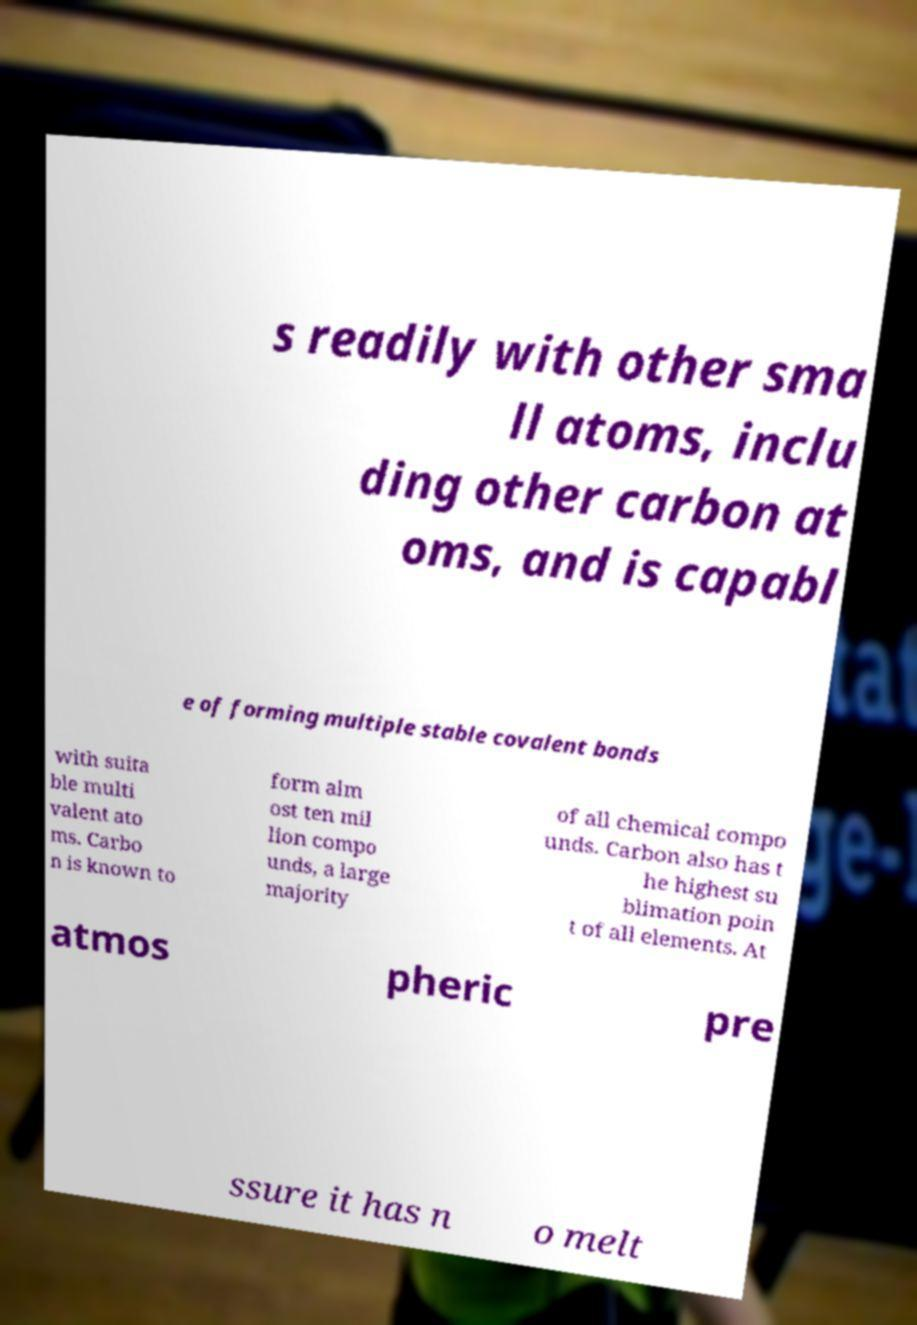Please read and relay the text visible in this image. What does it say? s readily with other sma ll atoms, inclu ding other carbon at oms, and is capabl e of forming multiple stable covalent bonds with suita ble multi valent ato ms. Carbo n is known to form alm ost ten mil lion compo unds, a large majority of all chemical compo unds. Carbon also has t he highest su blimation poin t of all elements. At atmos pheric pre ssure it has n o melt 